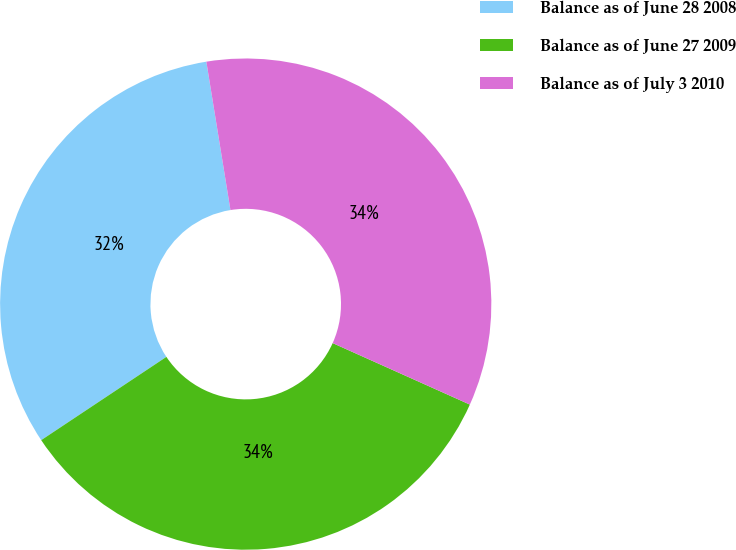<chart> <loc_0><loc_0><loc_500><loc_500><pie_chart><fcel>Balance as of June 28 2008<fcel>Balance as of June 27 2009<fcel>Balance as of July 3 2010<nl><fcel>31.78%<fcel>33.95%<fcel>34.27%<nl></chart> 